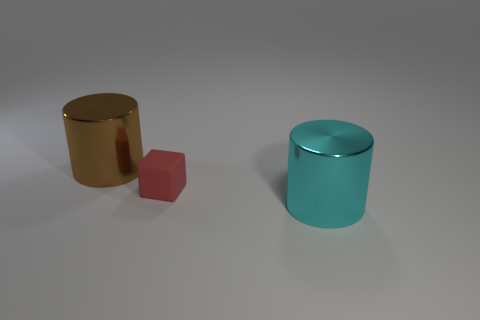Are there any large cyan objects that are behind the big metallic cylinder on the left side of the red cube?
Make the answer very short. No. What number of large cylinders are to the right of the metal cylinder that is in front of the large brown object?
Your answer should be very brief. 0. What material is the cyan cylinder that is the same size as the brown cylinder?
Give a very brief answer. Metal. There is a metal object behind the tiny thing; is its shape the same as the small object?
Your answer should be compact. No. Are there more large brown metal things that are in front of the cyan cylinder than brown objects that are left of the big brown metallic cylinder?
Offer a terse response. No. How many large brown cylinders are made of the same material as the small object?
Your answer should be very brief. 0. Is the cube the same size as the cyan cylinder?
Your answer should be compact. No. The tiny object has what color?
Offer a very short reply. Red. How many objects are either big objects or matte things?
Make the answer very short. 3. Are there any other metal things of the same shape as the large cyan thing?
Give a very brief answer. Yes. 